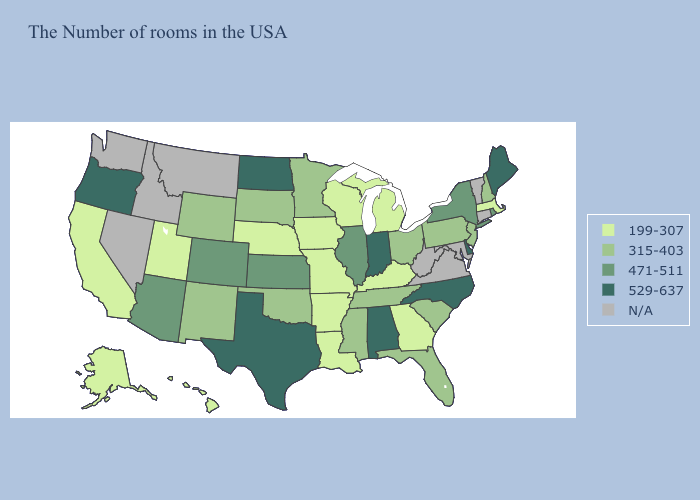Does New York have the highest value in the Northeast?
Answer briefly. No. Name the states that have a value in the range 199-307?
Write a very short answer. Massachusetts, Georgia, Michigan, Kentucky, Wisconsin, Louisiana, Missouri, Arkansas, Iowa, Nebraska, Utah, California, Alaska, Hawaii. Name the states that have a value in the range 529-637?
Quick response, please. Maine, Delaware, North Carolina, Indiana, Alabama, Texas, North Dakota, Oregon. Does the map have missing data?
Answer briefly. Yes. Name the states that have a value in the range 471-511?
Keep it brief. Rhode Island, New York, Illinois, Kansas, Colorado, Arizona. Which states have the highest value in the USA?
Answer briefly. Maine, Delaware, North Carolina, Indiana, Alabama, Texas, North Dakota, Oregon. What is the highest value in states that border Louisiana?
Write a very short answer. 529-637. What is the value of Indiana?
Answer briefly. 529-637. Among the states that border South Carolina , does Georgia have the highest value?
Short answer required. No. What is the value of Virginia?
Quick response, please. N/A. Is the legend a continuous bar?
Concise answer only. No. How many symbols are there in the legend?
Give a very brief answer. 5. What is the value of Colorado?
Keep it brief. 471-511. How many symbols are there in the legend?
Give a very brief answer. 5. 